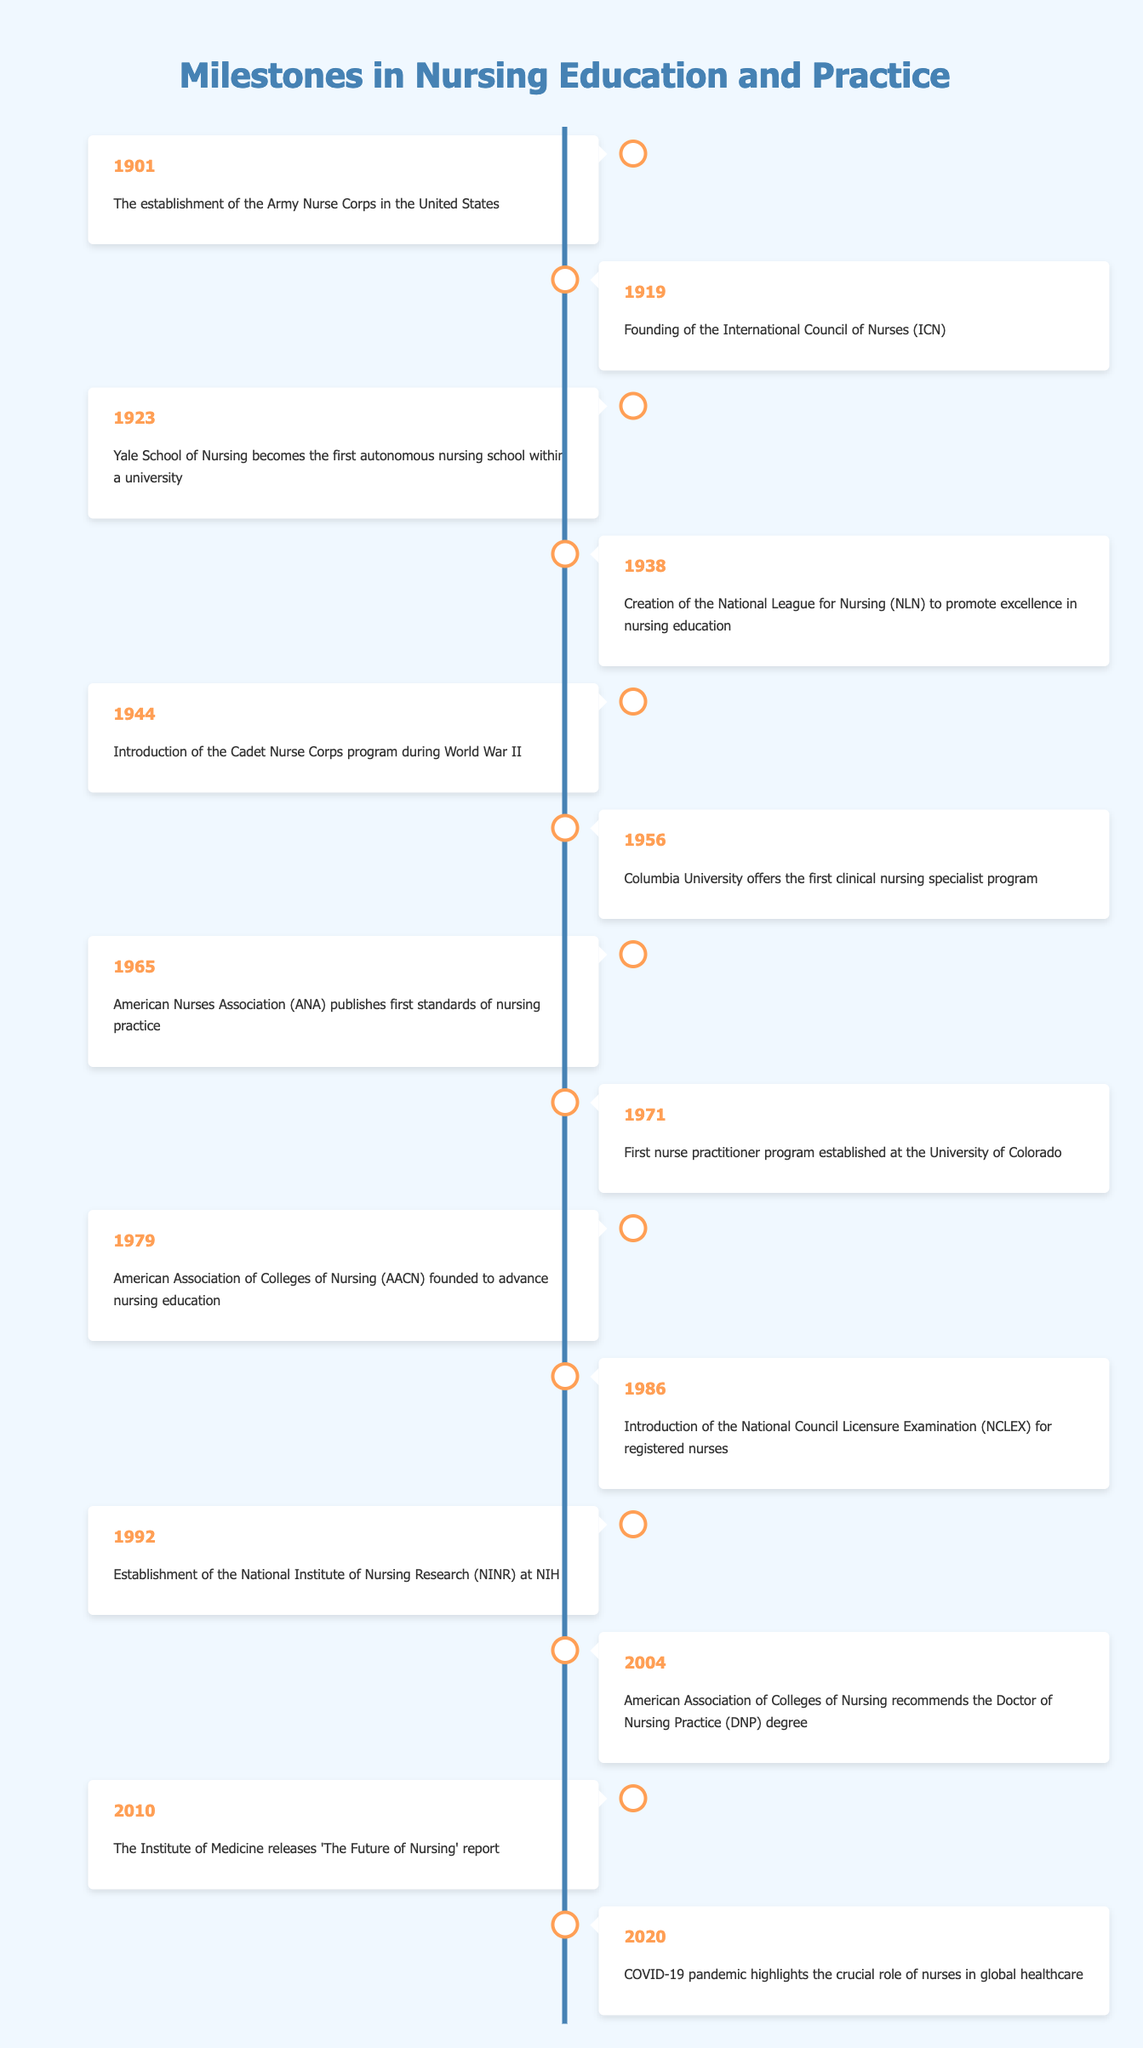What year was the Army Nurse Corps established? The Army Nurse Corps was established in the year 1901, as indicated in the first row of the table.
Answer: 1901 What event occurred in 1965? According to the table's entry for the year 1965, the American Nurses Association published the first standards of nursing practice.
Answer: American Nurses Association (ANA) publishes first standards of nursing practice How many milestones were recorded before 1950? By counting the entries from the table before the year 1950, there are 6 events listed (1901, 1919, 1923, 1938, 1944, 1956).
Answer: 6 Did the establishment of the National League for Nursing occur before or after 1930? The National League for Nursing was created in 1938, which is after 1930. Therefore, the answer is 'after'.
Answer: After Which two events are the most recent in this timeline? The two most recent events listed in the table are the publication of the 'Future of Nursing' report in 2010 and the highlighting of nurses’ roles during the COVID-19 pandemic in 2020. These two entries are found in the last rows of the table.
Answer: The Future of Nursing report (2010) and COVID-19 pandemic highlights (2020) What milestone can be considered the first major change to nursing practice standards? The first major change to nursing practice standards is reflected in 1965 with the publication of the first standards by the American Nurses Association. This signifies an important shift in defining nursing practices.
Answer: American Nurses Association (ANA) publishes first standards of nursing practice Calculate the difference in years between the founding of the International Council of Nurses and the introduction of the National Council Licensure Examination. The International Council of Nurses was founded in 1919, and the NCLEX was introduced in 1986. The difference is 1986 - 1919 = 67 years. This requires subtracting the earlier year from the later one to find the difference.
Answer: 67 years Which event signifies the introduction of a formal nursing education program during wartime? The introduction of the Cadet Nurse Corps program during World War II in 1944 signifies the establishment of a formal nursing education program in a wartime context. This can be found in the 1944 entry of the table.
Answer: Introduction of the Cadet Nurse Corps program during World War II (1944) What was the focus of the report released by the Institute of Medicine in 2010? The report released in 2010 by the Institute of Medicine titled 'The Future of Nursing' focuses on the future roles and contributions of nurses in healthcare, as stated in that entry.
Answer: The Future of Nursing report focuses on the future roles of nurses 